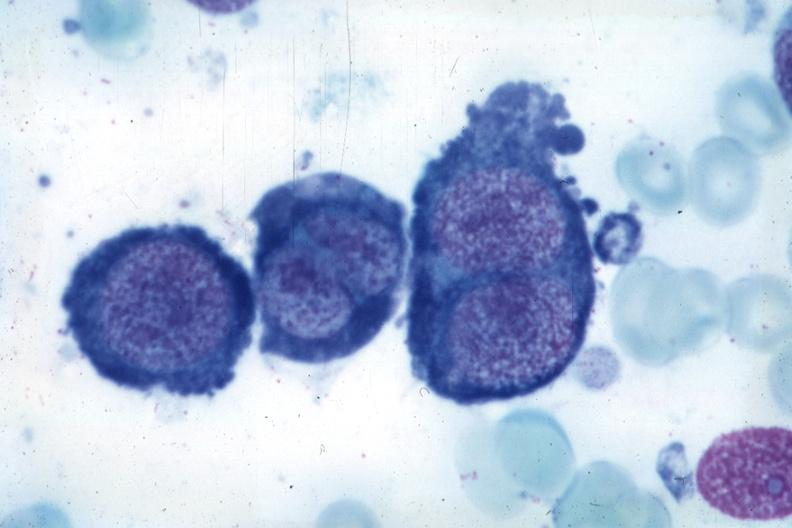what is present?
Answer the question using a single word or phrase. Bone marrow 